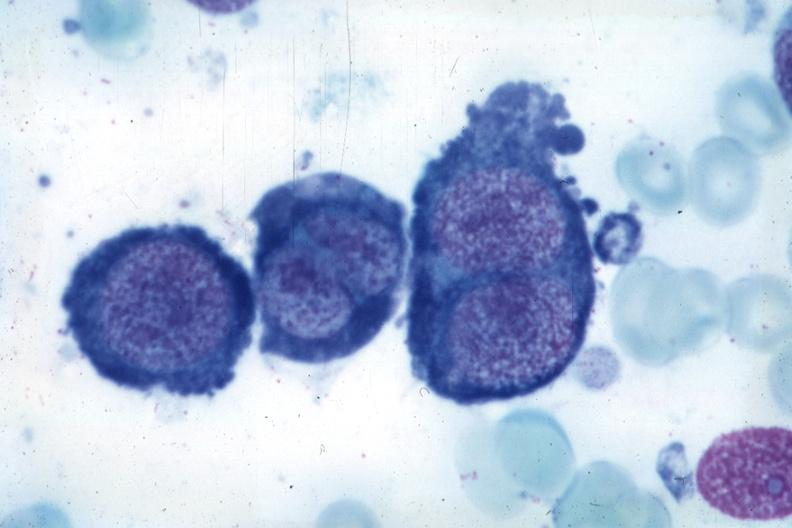what is present?
Answer the question using a single word or phrase. Bone marrow 